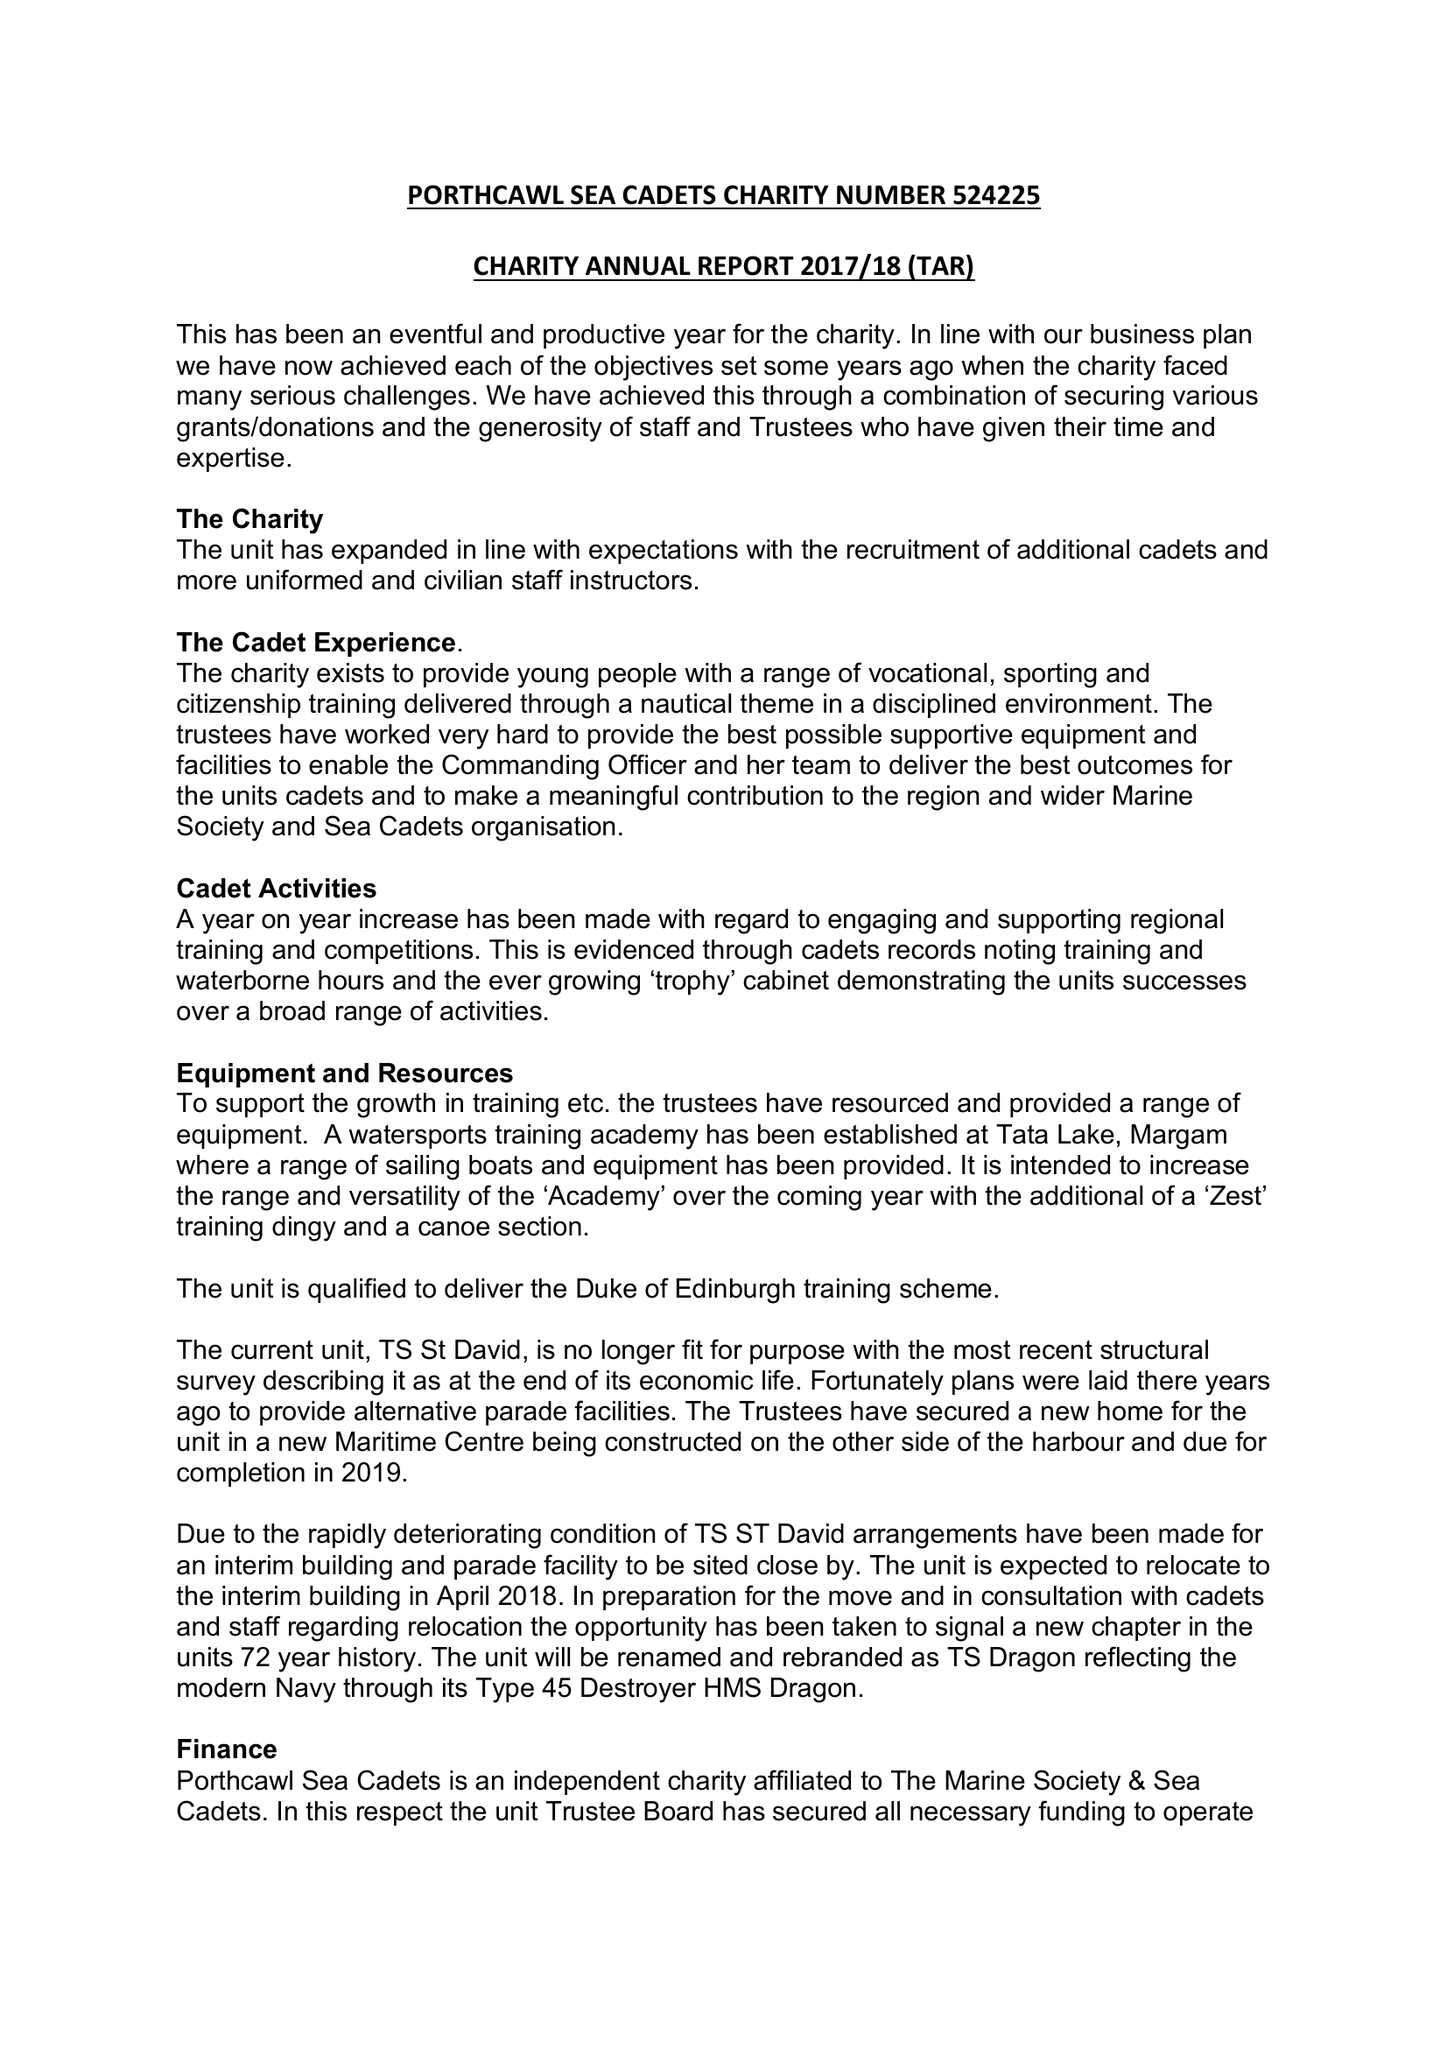What is the value for the spending_annually_in_british_pounds?
Answer the question using a single word or phrase. 48240.75 